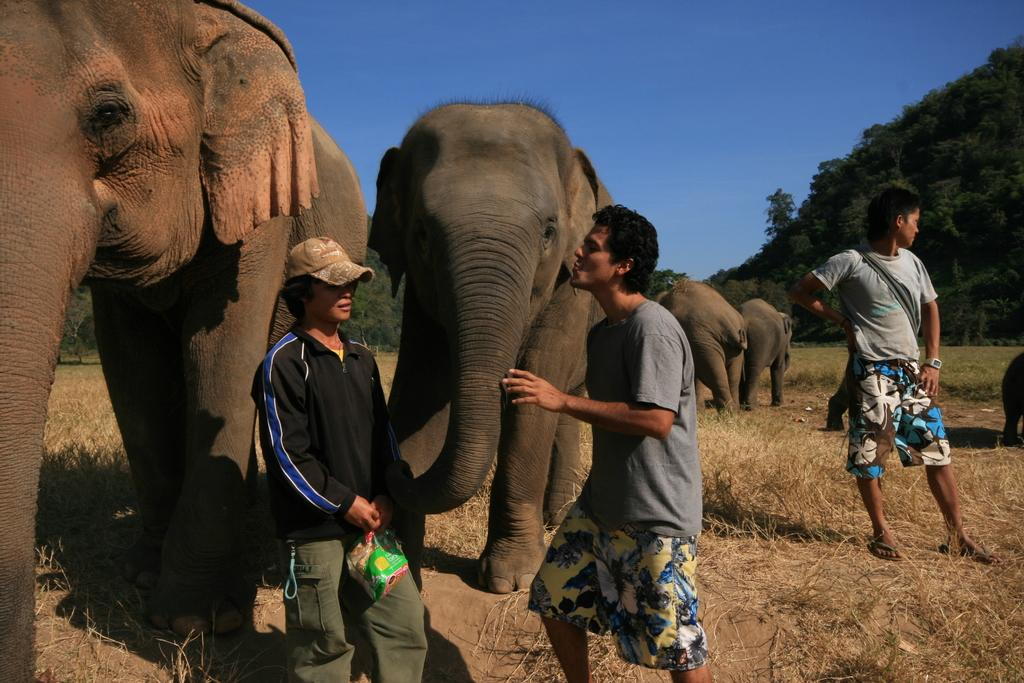What animals are present in the image? There are elephants in the image. What other subjects can be seen in the image besides the elephants? There are people standing in the image. What type of vegetation is visible in the background of the image? There are trees in the background of the image. What is visible in the sky in the background of the image? The sky is visible in the background of the image. What type of waves can be seen in the image? There are no waves present in the image. 